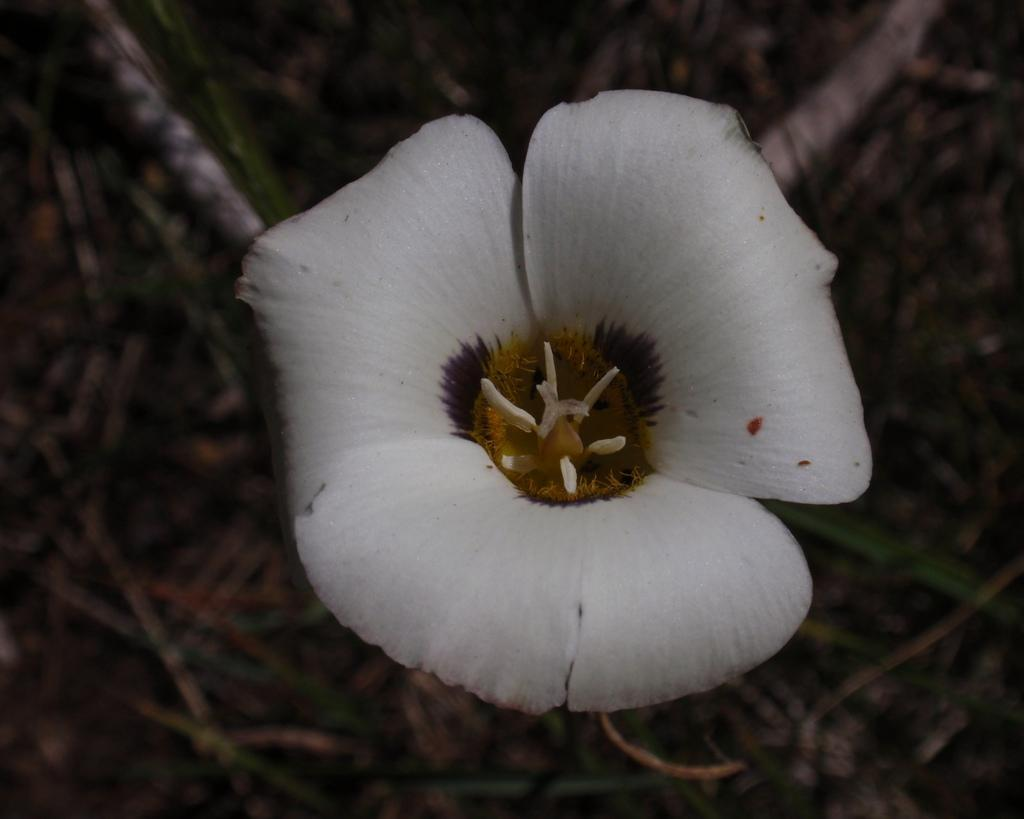What is the main subject of the image? There is a flower in the image. Can you describe the color of the flower? The flower is white. What can be seen in the background of the image? There are plants in the background of the image. Where are the plants located? The plants are on the land. What type of guide is helping the flower in the image? There is no guide present in the image, and the flower does not require assistance. 